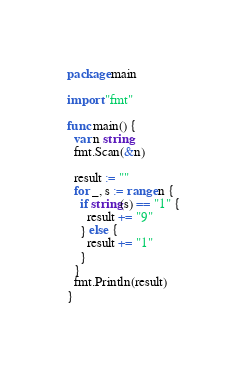<code> <loc_0><loc_0><loc_500><loc_500><_Go_>package main

import "fmt"

func main() {
  var n string
  fmt.Scan(&n)
  
  result := ""
  for _, s := range n {
    if string(s) == "1" {
      result += "9"
    } else {
      result += "1"
    }
  }
  fmt.Println(result)
}</code> 